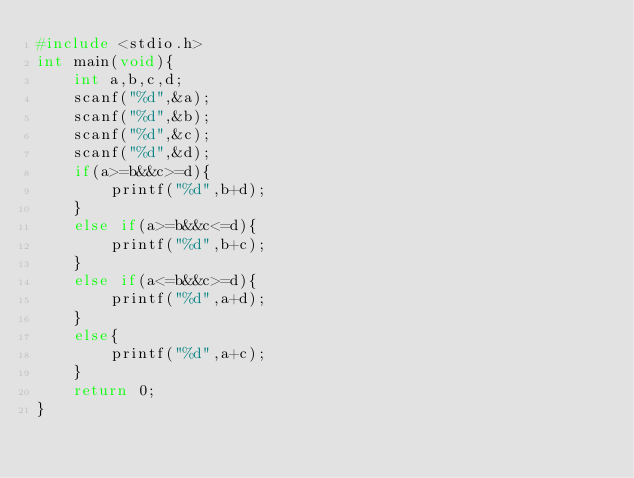<code> <loc_0><loc_0><loc_500><loc_500><_C_>#include <stdio.h>
int main(void){
    int a,b,c,d;
    scanf("%d",&a);
    scanf("%d",&b);
    scanf("%d",&c);
    scanf("%d",&d);
    if(a>=b&&c>=d){
        printf("%d",b+d);
    }
    else if(a>=b&&c<=d){
        printf("%d",b+c);
    }
    else if(a<=b&&c>=d){
        printf("%d",a+d);
    }
    else{
        printf("%d",a+c);
    }
    return 0;
}
</code> 